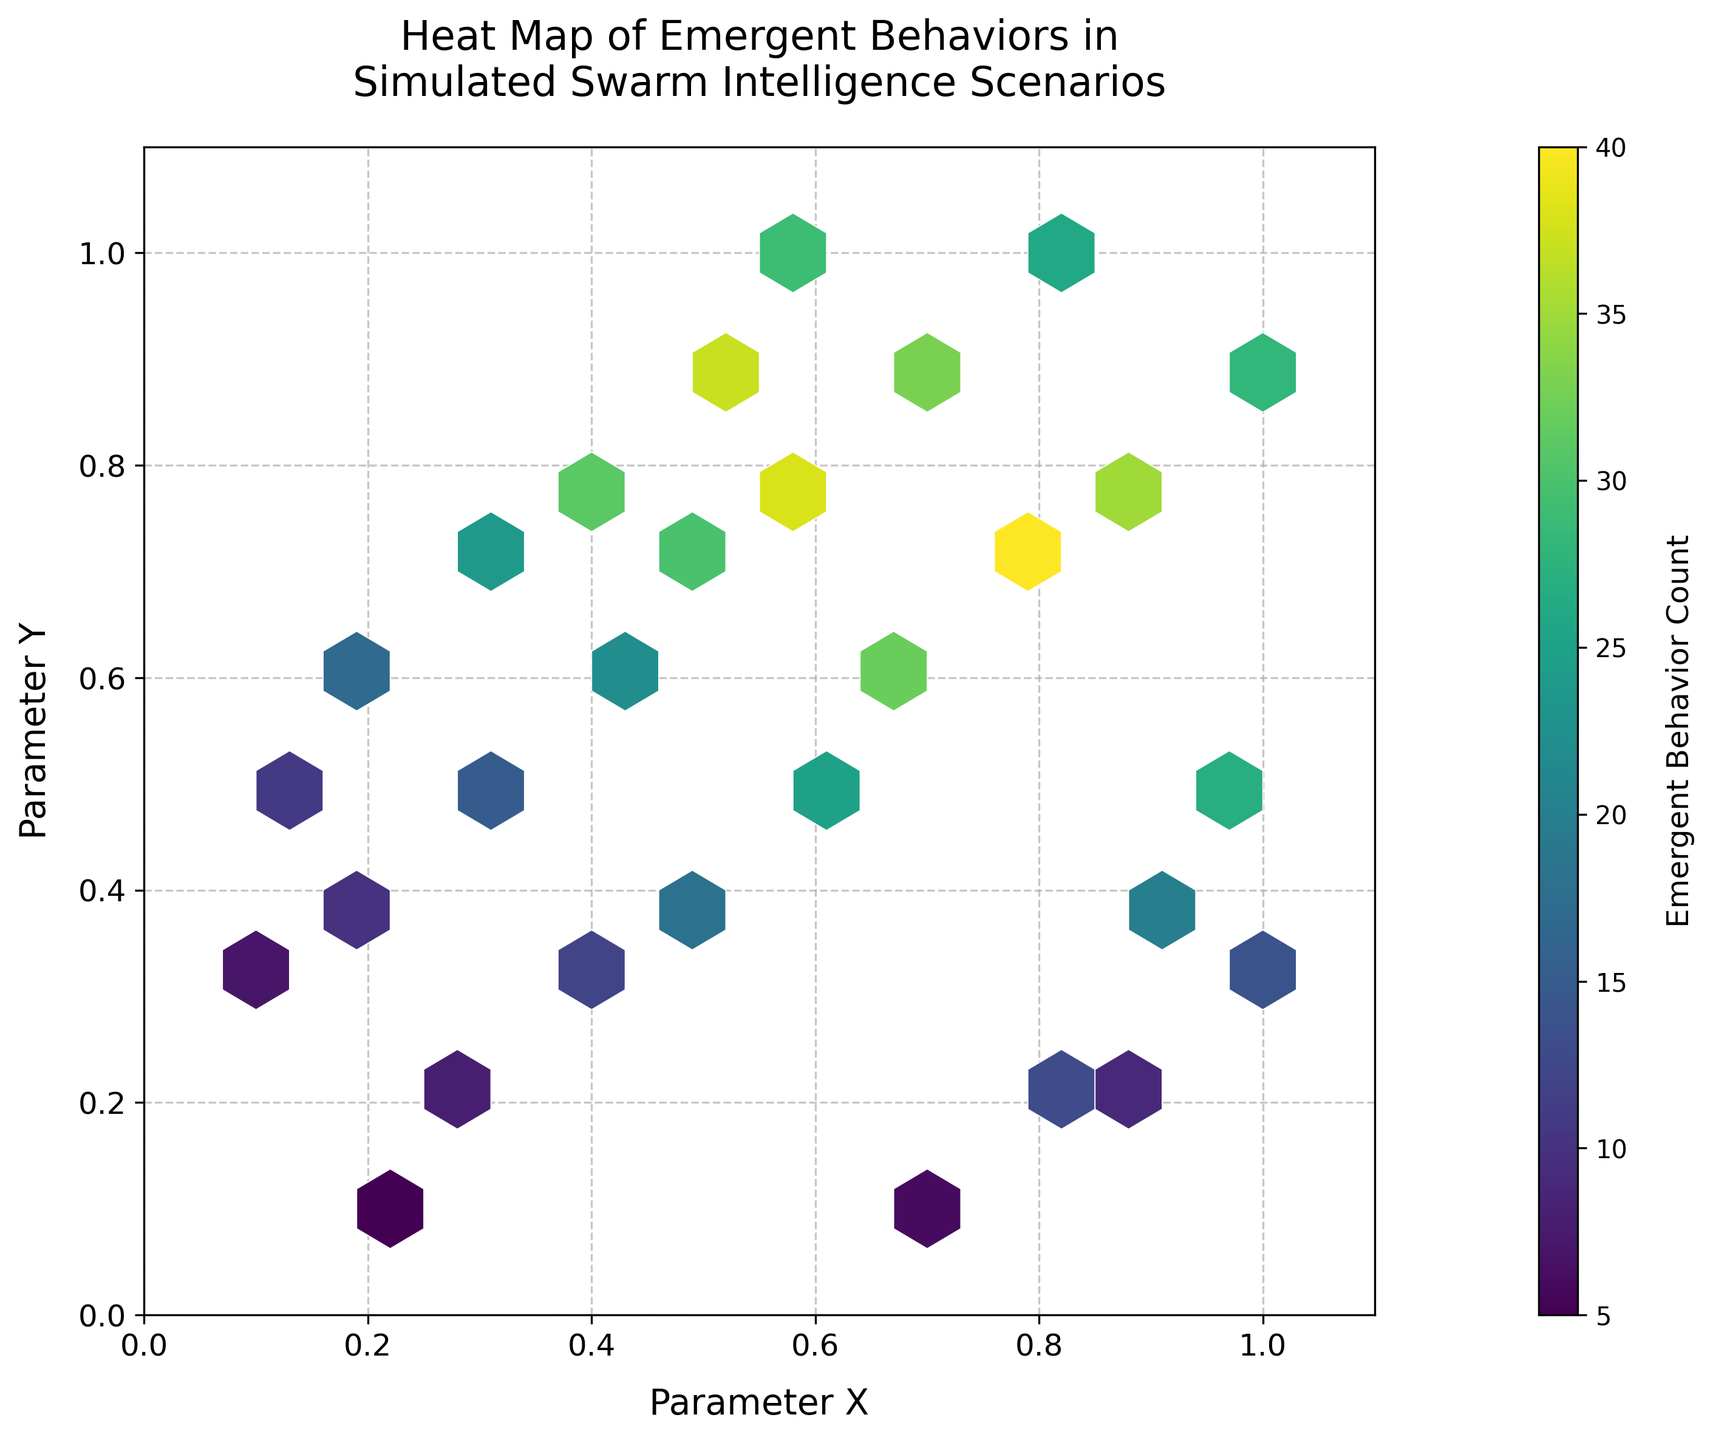What's the title of the plot? The title is displayed at the top of the plot, indicating that it is a "Heat Map of Emergent Behaviors in Simulated Swarm Intelligence Scenarios".
Answer: Heat Map of Emergent Behaviors in Simulated Swarm Intelligence Scenarios What do the axes labels represent? The labels along the x and y axes denote the variables represented in the plot. The x-axis is labeled as 'Parameter X', and the y-axis is labeled as 'Parameter Y'.
Answer: Parameter X and Parameter Y How many hexagons have the highest count of emergent behaviors? By observing the color gradient in the hexbin plot, the hexagons with the darkest color indicate the highest count. The related ones would be around (0.8, 0.7) and (0.6, 0.8).
Answer: 2 What is the color range used in the plot, and what does it signify? The color range starts from lighter shades to darker shades. Darker shades signify higher counts of emergent behaviors, while lighter shades indicate lower counts.
Answer: Light yellow to dark purple Which hexagon corresponds to the highest value of emergent behaviors and what are the corresponding parameters X and Y? The hexagon with the highest value is the darkest one in the plot. By checking the density, it's around (0.8, 0.7), which shows the highest count of 40.
Answer: (0.8, 0.7), 40 What is the trend observed as you move from the lower left to the upper right in the plot in terms of emergent behavior counts? By moving from the lower-left corner (low values of X and Y) to the upper-right corner (high values of X and Y), there is an observed increase in the counts indicated by the darker shades of hexagons.
Answer: Emergent behavior counts increase Compare the emergent behavior counts at (0.3,0.5) and (0.6,0.5). Which one is higher? By comparing the shades of the hexagons, the hexagon at (0.6,0.5) is darker, indicating a higher count of 25 compared to 15 at (0.3,0.5).
Answer: (0.6,0.5) is higher What is the average count of emergent behaviors for the data points where parameter X is 1? The counts of emergent behaviors for parameter X equal to 1 are 28, 14, and 27. Adding these gives 69, and dividing by 3 gives an average of 23.
Answer: 23 How does manipulating the grid size parameter of the hexbin plot influence the visual representation of emergent behaviors? Altering the grid size adjusts the number of hexagons; a smaller grid size results in larger hexagons covering larger data ranges, potentially hiding detailed patterns, while a larger grid size produces smaller hexagons that offer finer granularity.
Answer: Changes in detail granularity Between points (0.9,0.2) and (0.9,0.8), which point shows a higher emergent behavior count? Compare the colors of the hexagons at these points. The hexagon at (0.9,0.8) is darker with a count of 35, compared to 9 at (0.9,0.2).
Answer: (0.9,0.8) is higher 